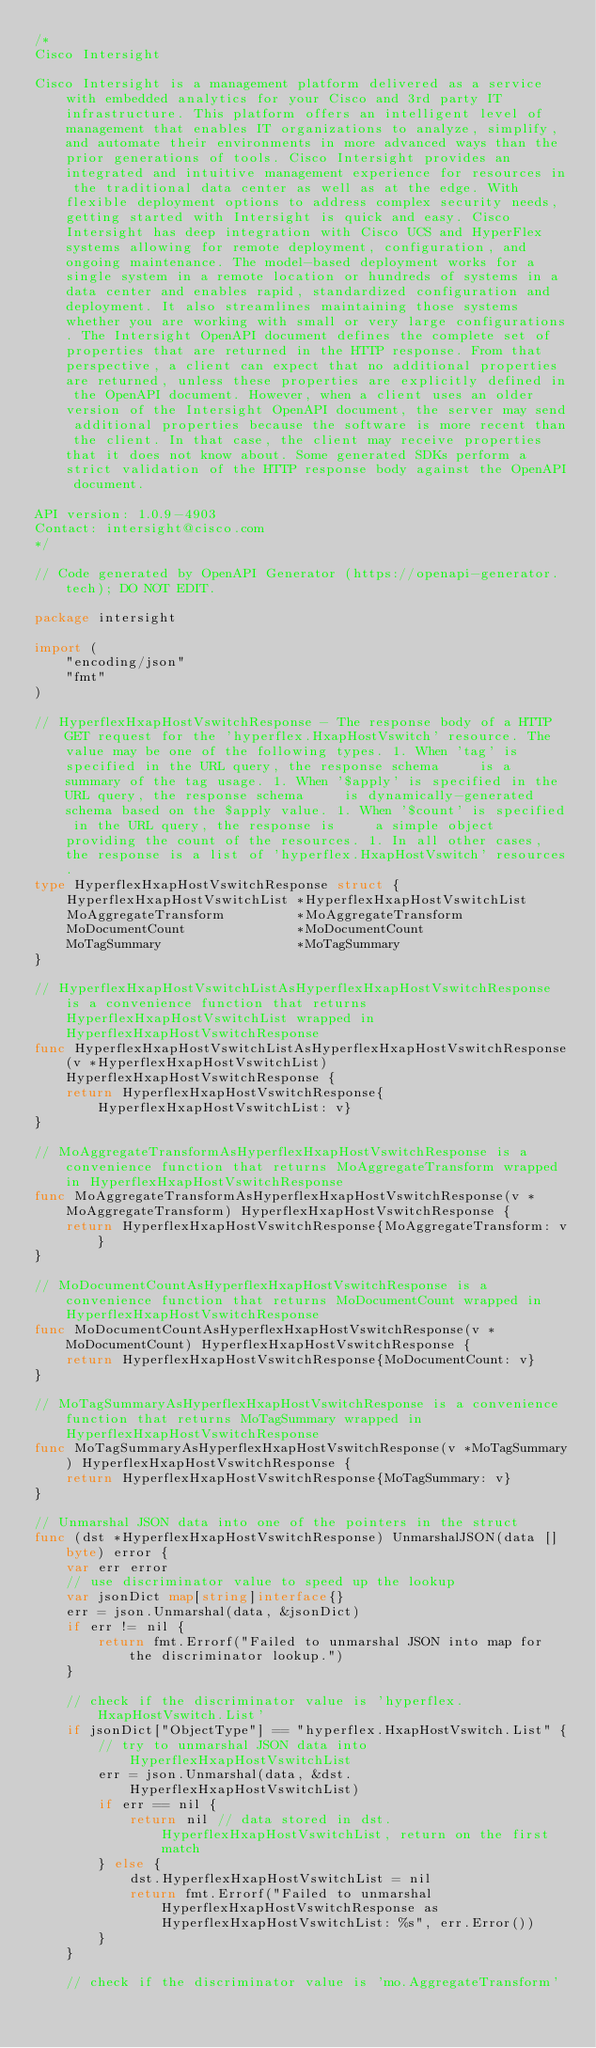Convert code to text. <code><loc_0><loc_0><loc_500><loc_500><_Go_>/*
Cisco Intersight

Cisco Intersight is a management platform delivered as a service with embedded analytics for your Cisco and 3rd party IT infrastructure. This platform offers an intelligent level of management that enables IT organizations to analyze, simplify, and automate their environments in more advanced ways than the prior generations of tools. Cisco Intersight provides an integrated and intuitive management experience for resources in the traditional data center as well as at the edge. With flexible deployment options to address complex security needs, getting started with Intersight is quick and easy. Cisco Intersight has deep integration with Cisco UCS and HyperFlex systems allowing for remote deployment, configuration, and ongoing maintenance. The model-based deployment works for a single system in a remote location or hundreds of systems in a data center and enables rapid, standardized configuration and deployment. It also streamlines maintaining those systems whether you are working with small or very large configurations. The Intersight OpenAPI document defines the complete set of properties that are returned in the HTTP response. From that perspective, a client can expect that no additional properties are returned, unless these properties are explicitly defined in the OpenAPI document. However, when a client uses an older version of the Intersight OpenAPI document, the server may send additional properties because the software is more recent than the client. In that case, the client may receive properties that it does not know about. Some generated SDKs perform a strict validation of the HTTP response body against the OpenAPI document.

API version: 1.0.9-4903
Contact: intersight@cisco.com
*/

// Code generated by OpenAPI Generator (https://openapi-generator.tech); DO NOT EDIT.

package intersight

import (
	"encoding/json"
	"fmt"
)

// HyperflexHxapHostVswitchResponse - The response body of a HTTP GET request for the 'hyperflex.HxapHostVswitch' resource. The value may be one of the following types. 1. When 'tag' is specified in the URL query, the response schema     is a summary of the tag usage. 1. When '$apply' is specified in the URL query, the response schema     is dynamically-generated schema based on the $apply value. 1. When '$count' is specified in the URL query, the response is     a simple object providing the count of the resources. 1. In all other cases, the response is a list of 'hyperflex.HxapHostVswitch' resources.
type HyperflexHxapHostVswitchResponse struct {
	HyperflexHxapHostVswitchList *HyperflexHxapHostVswitchList
	MoAggregateTransform         *MoAggregateTransform
	MoDocumentCount              *MoDocumentCount
	MoTagSummary                 *MoTagSummary
}

// HyperflexHxapHostVswitchListAsHyperflexHxapHostVswitchResponse is a convenience function that returns HyperflexHxapHostVswitchList wrapped in HyperflexHxapHostVswitchResponse
func HyperflexHxapHostVswitchListAsHyperflexHxapHostVswitchResponse(v *HyperflexHxapHostVswitchList) HyperflexHxapHostVswitchResponse {
	return HyperflexHxapHostVswitchResponse{HyperflexHxapHostVswitchList: v}
}

// MoAggregateTransformAsHyperflexHxapHostVswitchResponse is a convenience function that returns MoAggregateTransform wrapped in HyperflexHxapHostVswitchResponse
func MoAggregateTransformAsHyperflexHxapHostVswitchResponse(v *MoAggregateTransform) HyperflexHxapHostVswitchResponse {
	return HyperflexHxapHostVswitchResponse{MoAggregateTransform: v}
}

// MoDocumentCountAsHyperflexHxapHostVswitchResponse is a convenience function that returns MoDocumentCount wrapped in HyperflexHxapHostVswitchResponse
func MoDocumentCountAsHyperflexHxapHostVswitchResponse(v *MoDocumentCount) HyperflexHxapHostVswitchResponse {
	return HyperflexHxapHostVswitchResponse{MoDocumentCount: v}
}

// MoTagSummaryAsHyperflexHxapHostVswitchResponse is a convenience function that returns MoTagSummary wrapped in HyperflexHxapHostVswitchResponse
func MoTagSummaryAsHyperflexHxapHostVswitchResponse(v *MoTagSummary) HyperflexHxapHostVswitchResponse {
	return HyperflexHxapHostVswitchResponse{MoTagSummary: v}
}

// Unmarshal JSON data into one of the pointers in the struct
func (dst *HyperflexHxapHostVswitchResponse) UnmarshalJSON(data []byte) error {
	var err error
	// use discriminator value to speed up the lookup
	var jsonDict map[string]interface{}
	err = json.Unmarshal(data, &jsonDict)
	if err != nil {
		return fmt.Errorf("Failed to unmarshal JSON into map for the discriminator lookup.")
	}

	// check if the discriminator value is 'hyperflex.HxapHostVswitch.List'
	if jsonDict["ObjectType"] == "hyperflex.HxapHostVswitch.List" {
		// try to unmarshal JSON data into HyperflexHxapHostVswitchList
		err = json.Unmarshal(data, &dst.HyperflexHxapHostVswitchList)
		if err == nil {
			return nil // data stored in dst.HyperflexHxapHostVswitchList, return on the first match
		} else {
			dst.HyperflexHxapHostVswitchList = nil
			return fmt.Errorf("Failed to unmarshal HyperflexHxapHostVswitchResponse as HyperflexHxapHostVswitchList: %s", err.Error())
		}
	}

	// check if the discriminator value is 'mo.AggregateTransform'</code> 